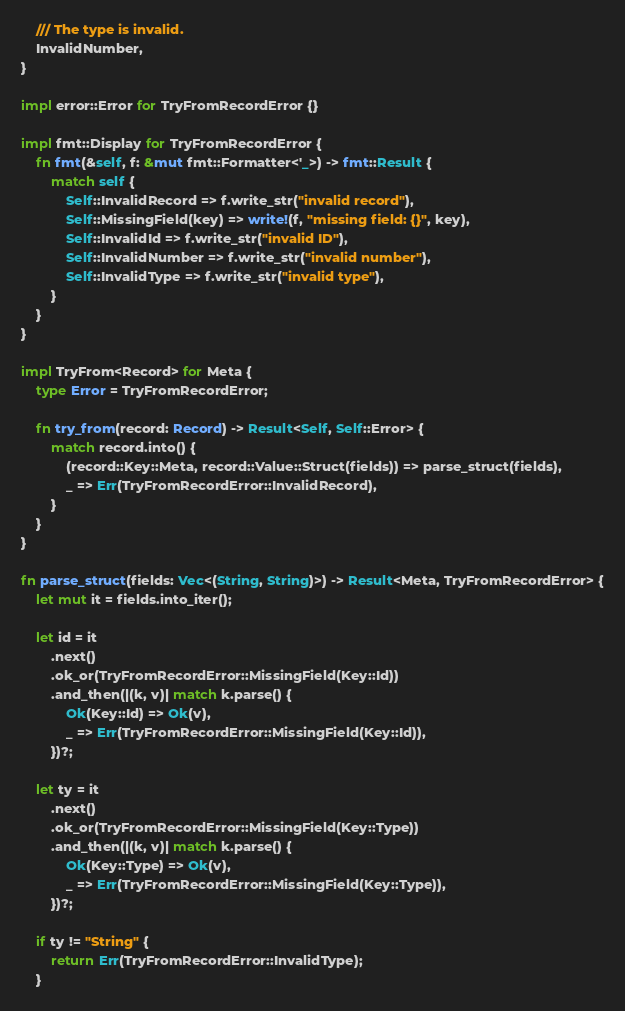Convert code to text. <code><loc_0><loc_0><loc_500><loc_500><_Rust_>    /// The type is invalid.
    InvalidNumber,
}

impl error::Error for TryFromRecordError {}

impl fmt::Display for TryFromRecordError {
    fn fmt(&self, f: &mut fmt::Formatter<'_>) -> fmt::Result {
        match self {
            Self::InvalidRecord => f.write_str("invalid record"),
            Self::MissingField(key) => write!(f, "missing field: {}", key),
            Self::InvalidId => f.write_str("invalid ID"),
            Self::InvalidNumber => f.write_str("invalid number"),
            Self::InvalidType => f.write_str("invalid type"),
        }
    }
}

impl TryFrom<Record> for Meta {
    type Error = TryFromRecordError;

    fn try_from(record: Record) -> Result<Self, Self::Error> {
        match record.into() {
            (record::Key::Meta, record::Value::Struct(fields)) => parse_struct(fields),
            _ => Err(TryFromRecordError::InvalidRecord),
        }
    }
}

fn parse_struct(fields: Vec<(String, String)>) -> Result<Meta, TryFromRecordError> {
    let mut it = fields.into_iter();

    let id = it
        .next()
        .ok_or(TryFromRecordError::MissingField(Key::Id))
        .and_then(|(k, v)| match k.parse() {
            Ok(Key::Id) => Ok(v),
            _ => Err(TryFromRecordError::MissingField(Key::Id)),
        })?;

    let ty = it
        .next()
        .ok_or(TryFromRecordError::MissingField(Key::Type))
        .and_then(|(k, v)| match k.parse() {
            Ok(Key::Type) => Ok(v),
            _ => Err(TryFromRecordError::MissingField(Key::Type)),
        })?;

    if ty != "String" {
        return Err(TryFromRecordError::InvalidType);
    }
</code> 